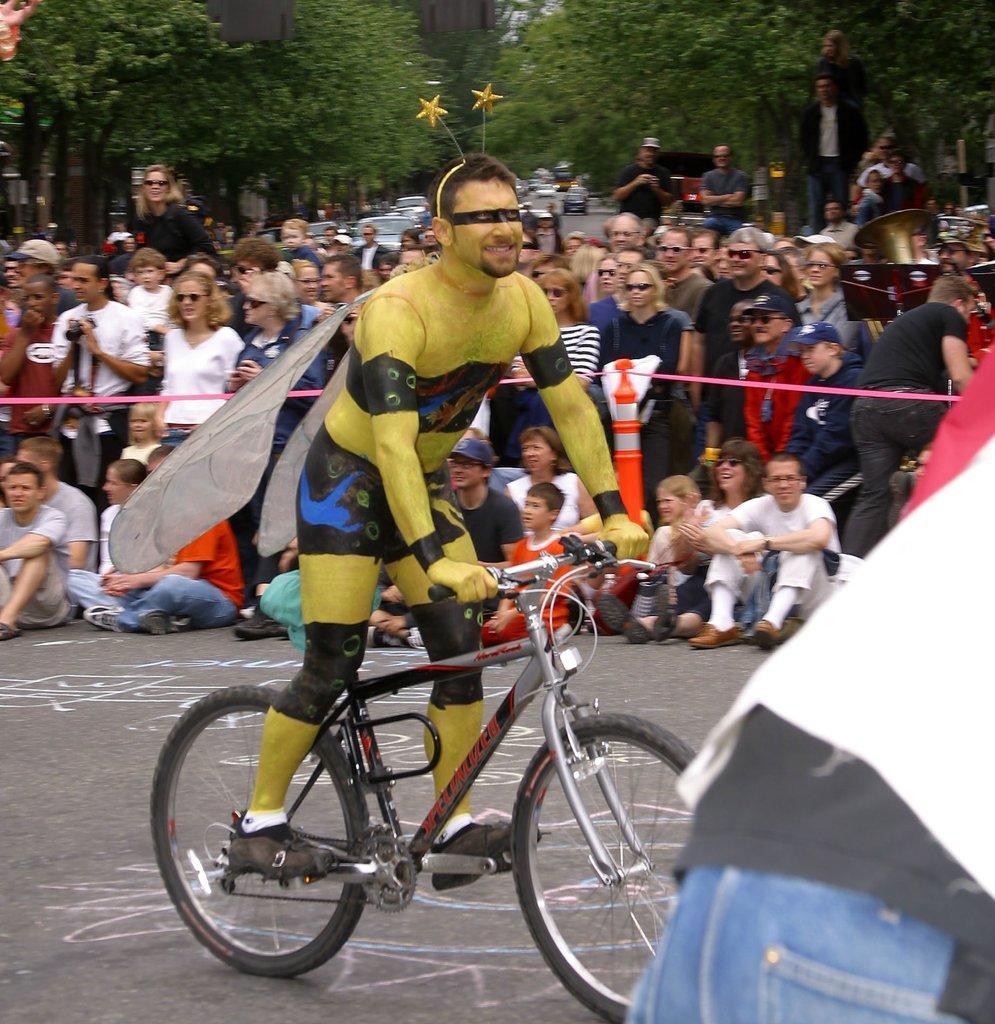How would you summarize this image in a sentence or two? In this image, there are some persons wearing colorful clothes. There is a person riding a bicycle. There are some trees and cars behind these persons. 